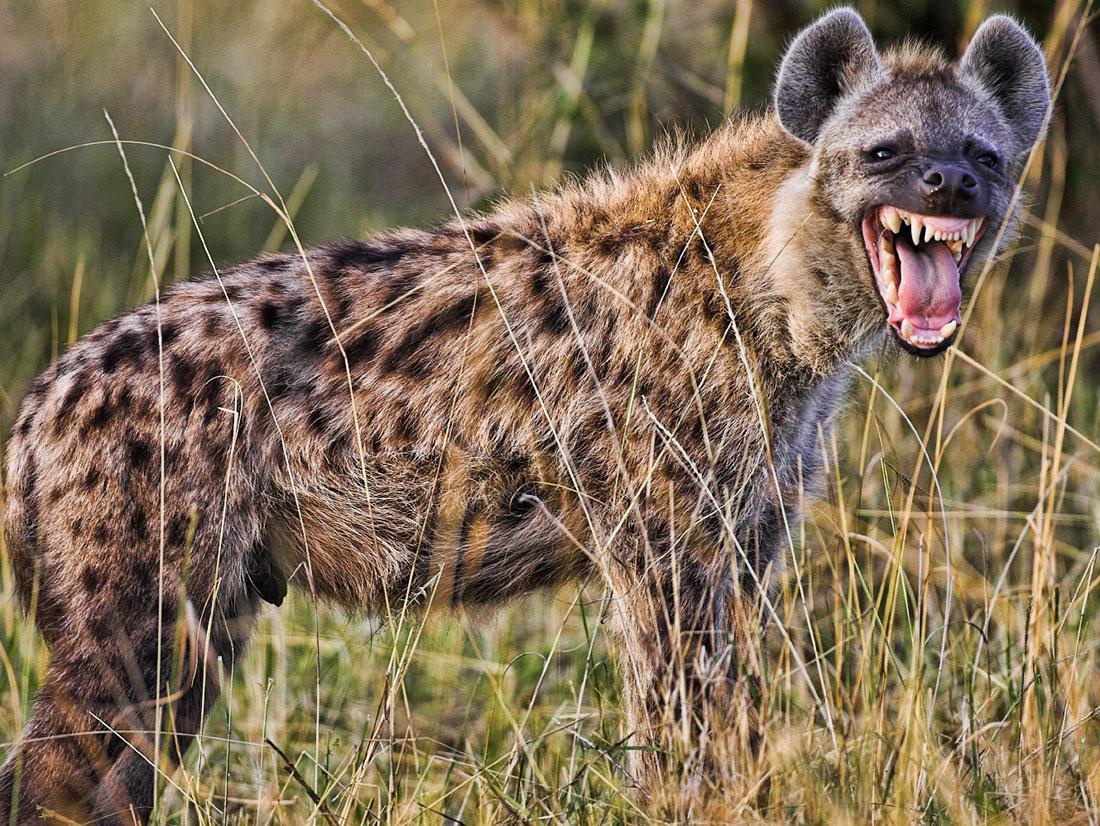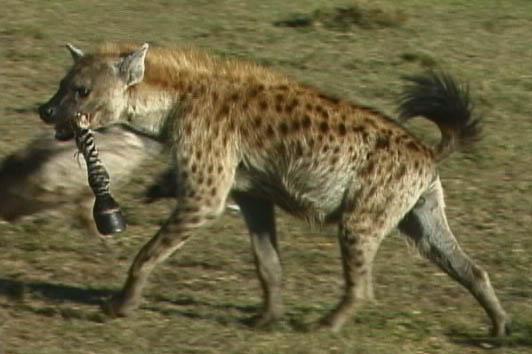The first image is the image on the left, the second image is the image on the right. Examine the images to the left and right. Is the description "There are exactly two hyenas in the image on the right." accurate? Answer yes or no. No. The first image is the image on the left, the second image is the image on the right. Assess this claim about the two images: "There are exactly two hyenas in each image.". Correct or not? Answer yes or no. No. 